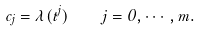<formula> <loc_0><loc_0><loc_500><loc_500>c _ { j } = \lambda ( t ^ { j } ) \quad j = 0 , \cdots , m .</formula> 